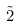Convert formula to latex. <formula><loc_0><loc_0><loc_500><loc_500>\tilde { 2 }</formula> 